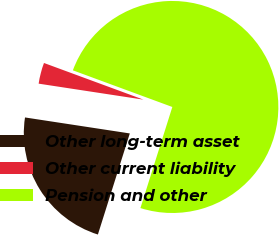Convert chart. <chart><loc_0><loc_0><loc_500><loc_500><pie_chart><fcel>Other long-term asset<fcel>Other current liability<fcel>Pension and other<nl><fcel>22.54%<fcel>3.21%<fcel>74.24%<nl></chart> 